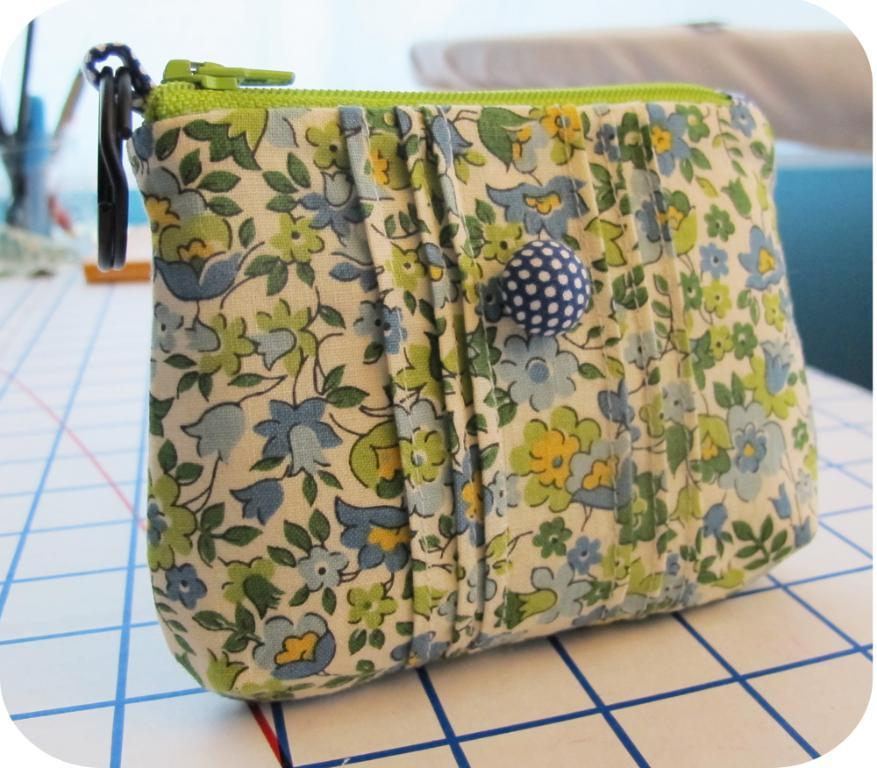What object is present in the image that might be used for carrying items? There is a bag in the image. Can you describe the design on the bag? The bag has a floral print. Where is the bag located in the image? The bag is kept on a table. What type of action is the cloth performing in the image? There is no cloth present in the image, and therefore no action can be attributed to it. 